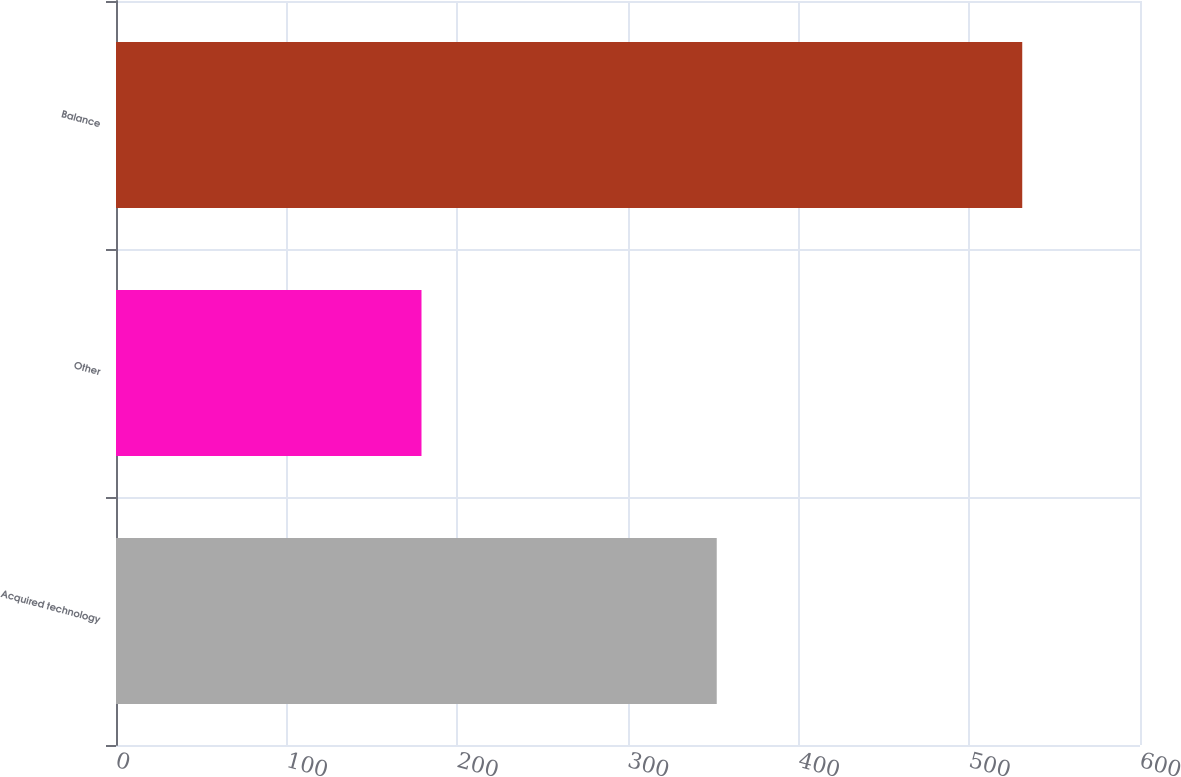Convert chart. <chart><loc_0><loc_0><loc_500><loc_500><bar_chart><fcel>Acquired technology<fcel>Other<fcel>Balance<nl><fcel>352<fcel>179<fcel>531<nl></chart> 